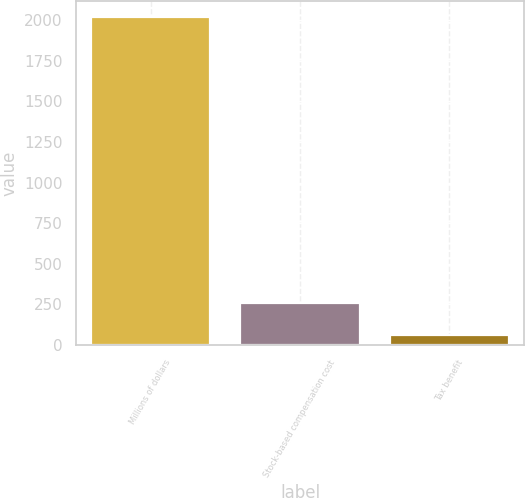<chart> <loc_0><loc_0><loc_500><loc_500><bar_chart><fcel>Millions of dollars<fcel>Stock-based compensation cost<fcel>Tax benefit<nl><fcel>2017<fcel>259.3<fcel>64<nl></chart> 